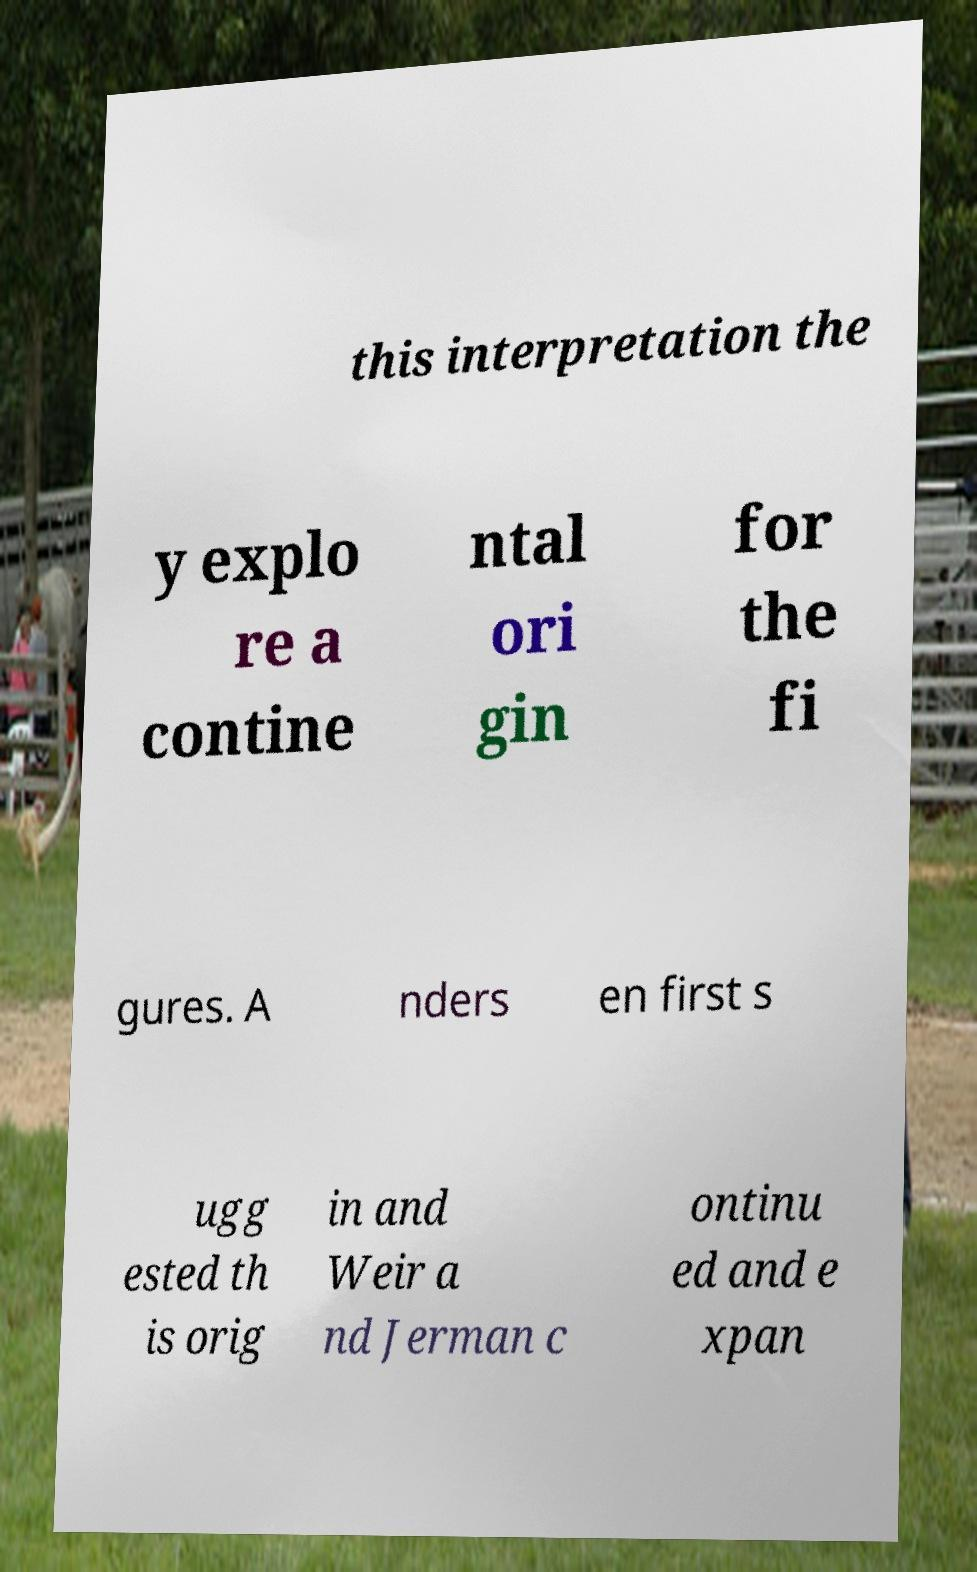Please identify and transcribe the text found in this image. this interpretation the y explo re a contine ntal ori gin for the fi gures. A nders en first s ugg ested th is orig in and Weir a nd Jerman c ontinu ed and e xpan 